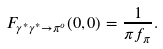Convert formula to latex. <formula><loc_0><loc_0><loc_500><loc_500>F _ { \gamma ^ { * } \gamma ^ { * } \to \pi ^ { o } } ( 0 , 0 ) = { \frac { 1 } { \pi f _ { \pi } } } .</formula> 